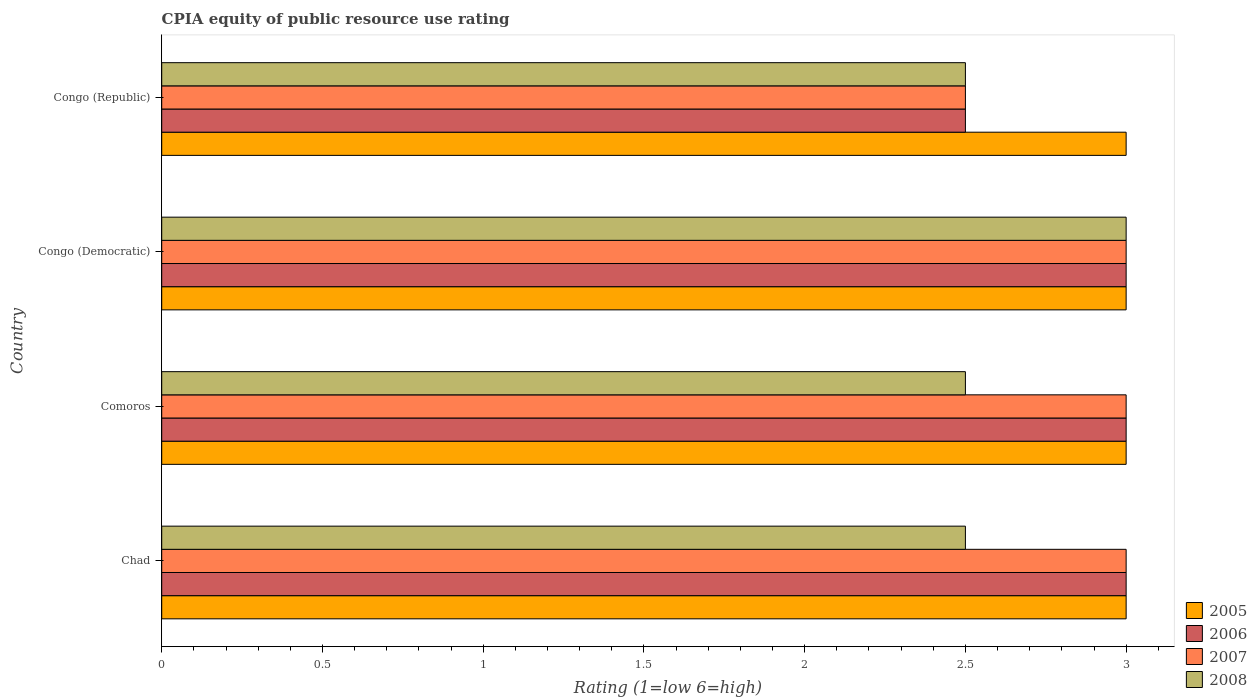How many different coloured bars are there?
Make the answer very short. 4. How many groups of bars are there?
Provide a short and direct response. 4. Are the number of bars on each tick of the Y-axis equal?
Offer a terse response. Yes. How many bars are there on the 3rd tick from the bottom?
Your answer should be very brief. 4. What is the label of the 3rd group of bars from the top?
Provide a succinct answer. Comoros. What is the CPIA rating in 2008 in Comoros?
Your response must be concise. 2.5. In which country was the CPIA rating in 2007 maximum?
Provide a succinct answer. Chad. In which country was the CPIA rating in 2008 minimum?
Offer a terse response. Chad. What is the difference between the CPIA rating in 2007 in Comoros and that in Congo (Democratic)?
Make the answer very short. 0. What is the average CPIA rating in 2005 per country?
Your answer should be compact. 3. In how many countries, is the CPIA rating in 2007 greater than 0.9 ?
Offer a very short reply. 4. What is the ratio of the CPIA rating in 2007 in Congo (Democratic) to that in Congo (Republic)?
Provide a succinct answer. 1.2. Is the difference between the CPIA rating in 2008 in Comoros and Congo (Democratic) greater than the difference between the CPIA rating in 2005 in Comoros and Congo (Democratic)?
Make the answer very short. No. What is the difference between the highest and the second highest CPIA rating in 2006?
Your answer should be very brief. 0. Is it the case that in every country, the sum of the CPIA rating in 2006 and CPIA rating in 2005 is greater than the sum of CPIA rating in 2008 and CPIA rating in 2007?
Your answer should be very brief. No. What does the 1st bar from the top in Congo (Republic) represents?
Ensure brevity in your answer.  2008. What does the 4th bar from the bottom in Chad represents?
Provide a short and direct response. 2008. Is it the case that in every country, the sum of the CPIA rating in 2005 and CPIA rating in 2007 is greater than the CPIA rating in 2006?
Ensure brevity in your answer.  Yes. How many bars are there?
Offer a very short reply. 16. Are all the bars in the graph horizontal?
Offer a terse response. Yes. Does the graph contain any zero values?
Ensure brevity in your answer.  No. How many legend labels are there?
Make the answer very short. 4. What is the title of the graph?
Offer a very short reply. CPIA equity of public resource use rating. What is the label or title of the X-axis?
Your response must be concise. Rating (1=low 6=high). What is the label or title of the Y-axis?
Ensure brevity in your answer.  Country. What is the Rating (1=low 6=high) in 2005 in Chad?
Provide a succinct answer. 3. What is the Rating (1=low 6=high) of 2006 in Chad?
Provide a succinct answer. 3. What is the Rating (1=low 6=high) of 2008 in Chad?
Your response must be concise. 2.5. What is the Rating (1=low 6=high) in 2005 in Comoros?
Give a very brief answer. 3. What is the Rating (1=low 6=high) in 2006 in Comoros?
Provide a short and direct response. 3. What is the Rating (1=low 6=high) in 2007 in Comoros?
Make the answer very short. 3. What is the Rating (1=low 6=high) in 2006 in Congo (Democratic)?
Offer a terse response. 3. What is the Rating (1=low 6=high) of 2005 in Congo (Republic)?
Offer a terse response. 3. What is the Rating (1=low 6=high) in 2006 in Congo (Republic)?
Make the answer very short. 2.5. What is the Rating (1=low 6=high) in 2007 in Congo (Republic)?
Give a very brief answer. 2.5. What is the Rating (1=low 6=high) in 2008 in Congo (Republic)?
Provide a succinct answer. 2.5. Across all countries, what is the maximum Rating (1=low 6=high) of 2005?
Your response must be concise. 3. Across all countries, what is the maximum Rating (1=low 6=high) in 2006?
Make the answer very short. 3. Across all countries, what is the maximum Rating (1=low 6=high) of 2008?
Provide a succinct answer. 3. Across all countries, what is the minimum Rating (1=low 6=high) of 2008?
Ensure brevity in your answer.  2.5. What is the total Rating (1=low 6=high) in 2005 in the graph?
Keep it short and to the point. 12. What is the difference between the Rating (1=low 6=high) in 2005 in Chad and that in Comoros?
Provide a succinct answer. 0. What is the difference between the Rating (1=low 6=high) of 2007 in Chad and that in Congo (Republic)?
Make the answer very short. 0.5. What is the difference between the Rating (1=low 6=high) of 2005 in Comoros and that in Congo (Democratic)?
Make the answer very short. 0. What is the difference between the Rating (1=low 6=high) of 2007 in Comoros and that in Congo (Democratic)?
Ensure brevity in your answer.  0. What is the difference between the Rating (1=low 6=high) of 2008 in Comoros and that in Congo (Republic)?
Provide a succinct answer. 0. What is the difference between the Rating (1=low 6=high) in 2005 in Congo (Democratic) and that in Congo (Republic)?
Your answer should be compact. 0. What is the difference between the Rating (1=low 6=high) in 2006 in Congo (Democratic) and that in Congo (Republic)?
Provide a short and direct response. 0.5. What is the difference between the Rating (1=low 6=high) of 2005 in Chad and the Rating (1=low 6=high) of 2007 in Comoros?
Make the answer very short. 0. What is the difference between the Rating (1=low 6=high) in 2006 in Chad and the Rating (1=low 6=high) in 2007 in Comoros?
Make the answer very short. 0. What is the difference between the Rating (1=low 6=high) in 2007 in Chad and the Rating (1=low 6=high) in 2008 in Comoros?
Make the answer very short. 0.5. What is the difference between the Rating (1=low 6=high) of 2005 in Chad and the Rating (1=low 6=high) of 2006 in Congo (Democratic)?
Your response must be concise. 0. What is the difference between the Rating (1=low 6=high) in 2005 in Chad and the Rating (1=low 6=high) in 2007 in Congo (Democratic)?
Offer a terse response. 0. What is the difference between the Rating (1=low 6=high) in 2005 in Chad and the Rating (1=low 6=high) in 2008 in Congo (Democratic)?
Provide a succinct answer. 0. What is the difference between the Rating (1=low 6=high) in 2005 in Chad and the Rating (1=low 6=high) in 2006 in Congo (Republic)?
Make the answer very short. 0.5. What is the difference between the Rating (1=low 6=high) of 2005 in Chad and the Rating (1=low 6=high) of 2007 in Congo (Republic)?
Provide a short and direct response. 0.5. What is the difference between the Rating (1=low 6=high) in 2005 in Chad and the Rating (1=low 6=high) in 2008 in Congo (Republic)?
Offer a very short reply. 0.5. What is the difference between the Rating (1=low 6=high) in 2006 in Chad and the Rating (1=low 6=high) in 2007 in Congo (Republic)?
Your response must be concise. 0.5. What is the difference between the Rating (1=low 6=high) of 2007 in Chad and the Rating (1=low 6=high) of 2008 in Congo (Republic)?
Provide a succinct answer. 0.5. What is the difference between the Rating (1=low 6=high) in 2005 in Comoros and the Rating (1=low 6=high) in 2006 in Congo (Democratic)?
Offer a terse response. 0. What is the difference between the Rating (1=low 6=high) in 2005 in Comoros and the Rating (1=low 6=high) in 2006 in Congo (Republic)?
Give a very brief answer. 0.5. What is the difference between the Rating (1=low 6=high) of 2005 in Comoros and the Rating (1=low 6=high) of 2007 in Congo (Republic)?
Keep it short and to the point. 0.5. What is the difference between the Rating (1=low 6=high) in 2005 in Comoros and the Rating (1=low 6=high) in 2008 in Congo (Republic)?
Your response must be concise. 0.5. What is the difference between the Rating (1=low 6=high) in 2007 in Comoros and the Rating (1=low 6=high) in 2008 in Congo (Republic)?
Offer a terse response. 0.5. What is the difference between the Rating (1=low 6=high) in 2005 in Congo (Democratic) and the Rating (1=low 6=high) in 2007 in Congo (Republic)?
Offer a terse response. 0.5. What is the difference between the Rating (1=low 6=high) in 2005 in Congo (Democratic) and the Rating (1=low 6=high) in 2008 in Congo (Republic)?
Keep it short and to the point. 0.5. What is the difference between the Rating (1=low 6=high) in 2006 in Congo (Democratic) and the Rating (1=low 6=high) in 2007 in Congo (Republic)?
Your response must be concise. 0.5. What is the difference between the Rating (1=low 6=high) in 2006 in Congo (Democratic) and the Rating (1=low 6=high) in 2008 in Congo (Republic)?
Provide a succinct answer. 0.5. What is the average Rating (1=low 6=high) of 2006 per country?
Your answer should be compact. 2.88. What is the average Rating (1=low 6=high) in 2007 per country?
Keep it short and to the point. 2.88. What is the average Rating (1=low 6=high) of 2008 per country?
Offer a terse response. 2.62. What is the difference between the Rating (1=low 6=high) in 2005 and Rating (1=low 6=high) in 2006 in Chad?
Provide a short and direct response. 0. What is the difference between the Rating (1=low 6=high) in 2005 and Rating (1=low 6=high) in 2007 in Chad?
Keep it short and to the point. 0. What is the difference between the Rating (1=low 6=high) of 2005 and Rating (1=low 6=high) of 2008 in Chad?
Your response must be concise. 0.5. What is the difference between the Rating (1=low 6=high) in 2006 and Rating (1=low 6=high) in 2008 in Chad?
Your response must be concise. 0.5. What is the difference between the Rating (1=low 6=high) in 2006 and Rating (1=low 6=high) in 2007 in Comoros?
Keep it short and to the point. 0. What is the difference between the Rating (1=low 6=high) of 2006 and Rating (1=low 6=high) of 2008 in Comoros?
Keep it short and to the point. 0.5. What is the difference between the Rating (1=low 6=high) of 2007 and Rating (1=low 6=high) of 2008 in Comoros?
Keep it short and to the point. 0.5. What is the difference between the Rating (1=low 6=high) of 2005 and Rating (1=low 6=high) of 2007 in Congo (Democratic)?
Offer a very short reply. 0. What is the difference between the Rating (1=low 6=high) of 2005 and Rating (1=low 6=high) of 2006 in Congo (Republic)?
Provide a short and direct response. 0.5. What is the difference between the Rating (1=low 6=high) of 2005 and Rating (1=low 6=high) of 2007 in Congo (Republic)?
Your response must be concise. 0.5. What is the ratio of the Rating (1=low 6=high) of 2005 in Chad to that in Comoros?
Provide a succinct answer. 1. What is the ratio of the Rating (1=low 6=high) in 2006 in Chad to that in Comoros?
Offer a terse response. 1. What is the ratio of the Rating (1=low 6=high) in 2008 in Chad to that in Comoros?
Keep it short and to the point. 1. What is the ratio of the Rating (1=low 6=high) of 2006 in Chad to that in Congo (Democratic)?
Your answer should be compact. 1. What is the ratio of the Rating (1=low 6=high) of 2005 in Chad to that in Congo (Republic)?
Provide a succinct answer. 1. What is the ratio of the Rating (1=low 6=high) in 2007 in Chad to that in Congo (Republic)?
Your answer should be compact. 1.2. What is the ratio of the Rating (1=low 6=high) in 2006 in Comoros to that in Congo (Democratic)?
Give a very brief answer. 1. What is the ratio of the Rating (1=low 6=high) in 2007 in Comoros to that in Congo (Democratic)?
Offer a terse response. 1. What is the ratio of the Rating (1=low 6=high) in 2008 in Comoros to that in Congo (Republic)?
Your answer should be very brief. 1. What is the ratio of the Rating (1=low 6=high) in 2006 in Congo (Democratic) to that in Congo (Republic)?
Give a very brief answer. 1.2. What is the ratio of the Rating (1=low 6=high) of 2008 in Congo (Democratic) to that in Congo (Republic)?
Offer a very short reply. 1.2. What is the difference between the highest and the second highest Rating (1=low 6=high) in 2006?
Offer a terse response. 0. What is the difference between the highest and the second highest Rating (1=low 6=high) in 2007?
Your answer should be very brief. 0. What is the difference between the highest and the second highest Rating (1=low 6=high) of 2008?
Provide a short and direct response. 0.5. 